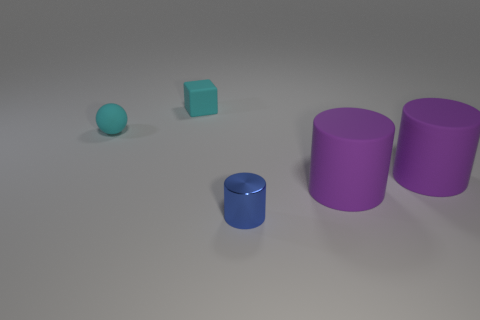Add 4 tiny cyan cubes. How many objects exist? 9 Subtract all cubes. How many objects are left? 4 Add 3 small blue shiny cylinders. How many small blue shiny cylinders are left? 4 Add 4 big matte things. How many big matte things exist? 6 Subtract 0 cyan cylinders. How many objects are left? 5 Subtract all purple objects. Subtract all purple matte things. How many objects are left? 1 